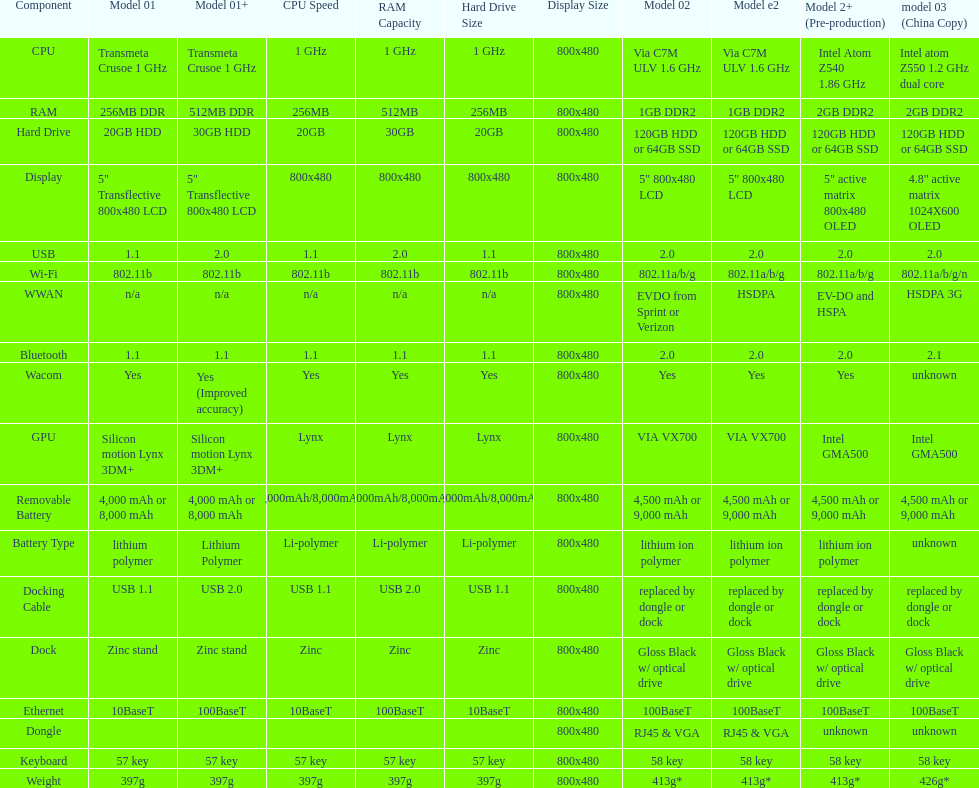The model 2 and the model 2e have what type of cpu? Via C7M ULV 1.6 GHz. 